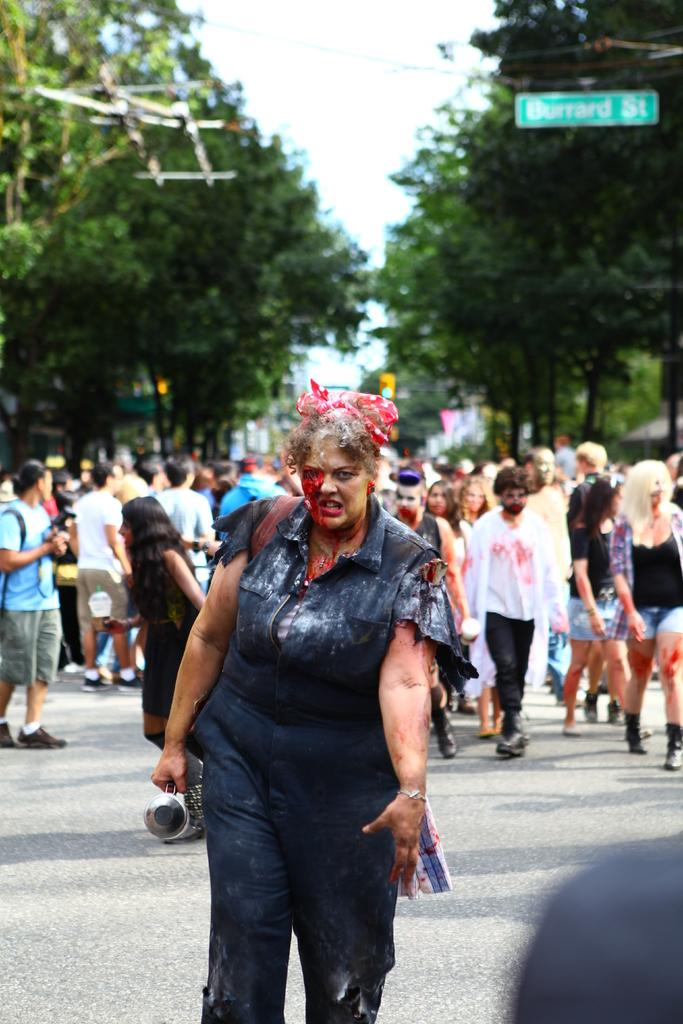What is the lady in the image wearing? There is a lady wearing a costume in the image. What can be seen in the background of the image? There are trees and sky visible in the background of the image. What object is present in the image? There is a board in the image. How many people are in the image? There are people in the image. What type of ink is being used to write on the board in the image? There is no indication in the image that anything is being written on the board, so it cannot be determined if ink is being used. 